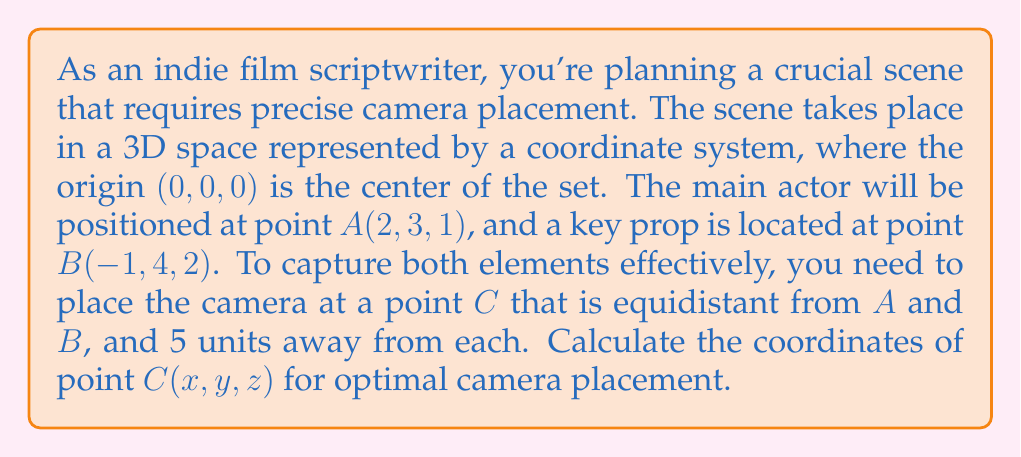Help me with this question. To solve this problem, we'll follow these steps:

1) First, we need to use the distance formula in 3D space. The distance between two points $(x_1, y_1, z_1)$ and $(x_2, y_2, z_2)$ is given by:

   $$d = \sqrt{(x_2-x_1)^2 + (y_2-y_1)^2 + (z_2-z_1)^2}$$

2) We know that the distance from C to both A and B is 5 units. So we can set up two equations:

   $$\sqrt{(x-2)^2 + (y-3)^2 + (z-1)^2} = 5$$
   $$\sqrt{(x+1)^2 + (y-4)^2 + (z-2)^2} = 5$$

3) Square both sides of each equation:

   $$(x-2)^2 + (y-3)^2 + (z-1)^2 = 25$$
   $$(x+1)^2 + (y-4)^2 + (z-2)^2 = 25$$

4) Expand these equations:

   $$x^2-4x+4 + y^2-6y+9 + z^2-2z+1 = 25$$
   $$x^2+2x+1 + y^2-8y+16 + z^2-4z+4 = 25$$

5) Subtract the first equation from the second:

   $$6x - 2y - 2z + 7 = 0$$

6) This is the equation of a plane that contains all points equidistant from A and B. The camera position C must lie on this plane.

7) To find the specific point C, we need to combine this equation with the fact that C is 5 units from A (or B). Let's use the equation with A:

   $$(x-2)^2 + (y-3)^2 + (z-1)^2 = 25$$

8) We now have a system of two equations with three unknowns. To solve this, we can use the equation of the plane to express z in terms of x and y:

   $$z = 3x - y + \frac{7}{2}$$

9) Substitute this into the distance equation:

   $$(x-2)^2 + (y-3)^2 + (3x-y+\frac{7}{2}-1)^2 = 25$$

10) Expand and simplify this equation. It will result in a complex equation of x and y. Due to the symmetry of the problem, we can deduce that the point C will have the same y-coordinate as the midpoint of A and B, which is $\frac{3+4}{2} = 3.5$.

11) Substitute $y = 3.5$ into the plane equation:

    $$6x - 2(3.5) - 2z + 7 = 0$$
    $$6x - 2z = 0$$
    $$3x = z$$

12) Now substitute both $y = 3.5$ and $z = 3x$ into the distance equation:

    $$(x-2)^2 + (3.5-3)^2 + (3x-1)^2 = 25$$

13) Solve this equation for x. You'll find that $x = 0.5$.

14) Now we can find z: $z = 3(0.5) = 1.5$

Therefore, the coordinates of point C are (0.5, 3.5, 1.5).
Answer: The optimal camera placement is at point C(0.5, 3.5, 1.5). 